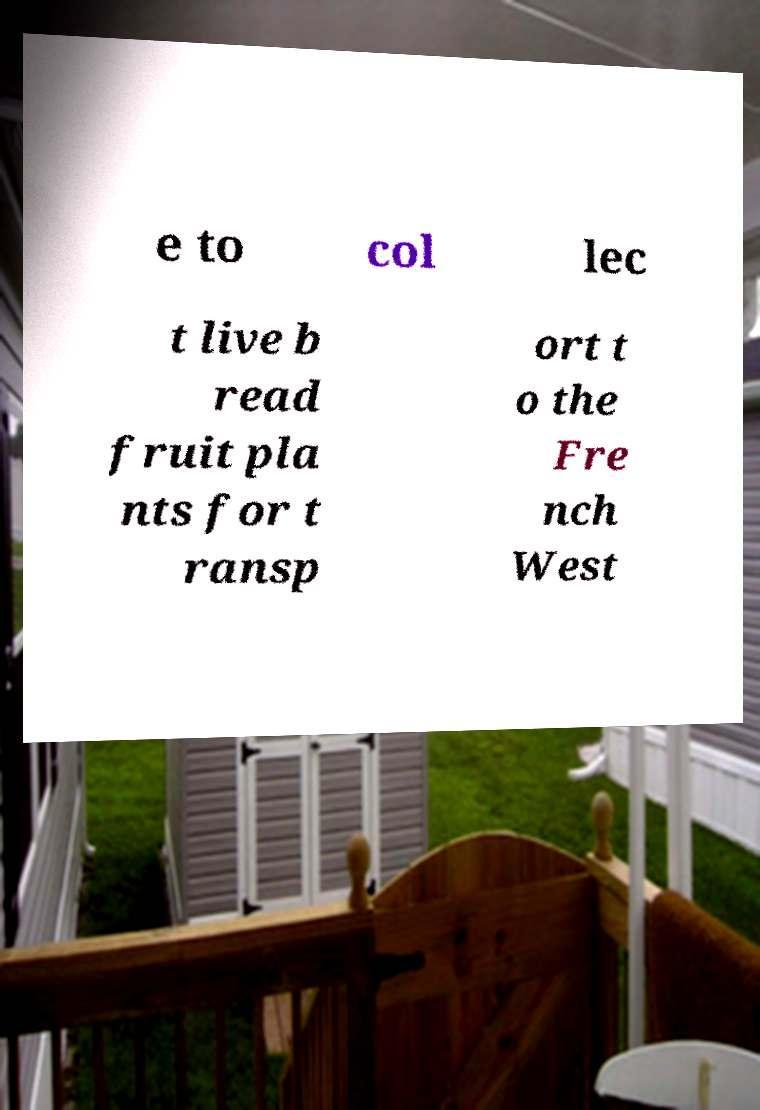Please read and relay the text visible in this image. What does it say? e to col lec t live b read fruit pla nts for t ransp ort t o the Fre nch West 